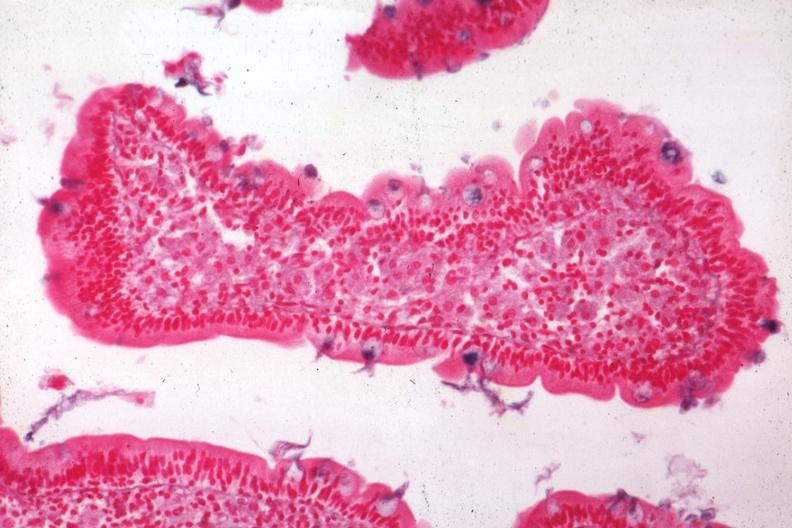s hypertrophic gastritis present?
Answer the question using a single word or phrase. No 